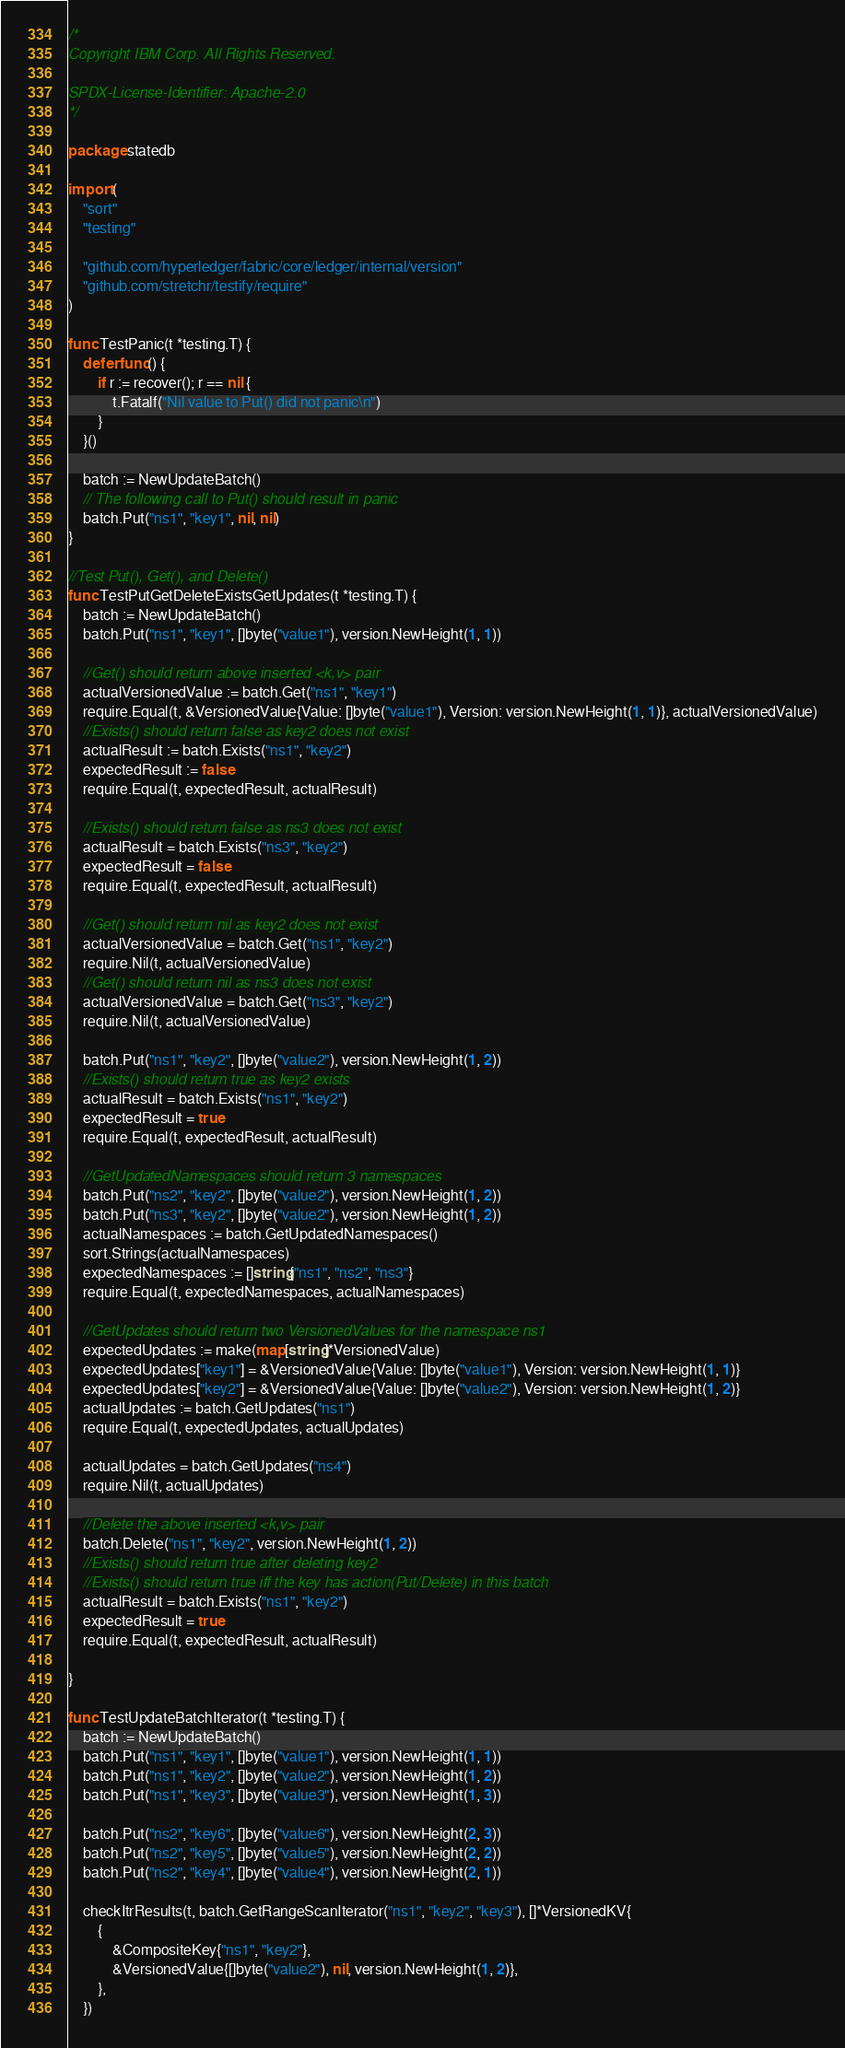<code> <loc_0><loc_0><loc_500><loc_500><_Go_>/*
Copyright IBM Corp. All Rights Reserved.

SPDX-License-Identifier: Apache-2.0
*/

package statedb

import (
	"sort"
	"testing"

	"github.com/hyperledger/fabric/core/ledger/internal/version"
	"github.com/stretchr/testify/require"
)

func TestPanic(t *testing.T) {
	defer func() {
		if r := recover(); r == nil {
			t.Fatalf("Nil value to Put() did not panic\n")
		}
	}()

	batch := NewUpdateBatch()
	// The following call to Put() should result in panic
	batch.Put("ns1", "key1", nil, nil)
}

//Test Put(), Get(), and Delete()
func TestPutGetDeleteExistsGetUpdates(t *testing.T) {
	batch := NewUpdateBatch()
	batch.Put("ns1", "key1", []byte("value1"), version.NewHeight(1, 1))

	//Get() should return above inserted <k,v> pair
	actualVersionedValue := batch.Get("ns1", "key1")
	require.Equal(t, &VersionedValue{Value: []byte("value1"), Version: version.NewHeight(1, 1)}, actualVersionedValue)
	//Exists() should return false as key2 does not exist
	actualResult := batch.Exists("ns1", "key2")
	expectedResult := false
	require.Equal(t, expectedResult, actualResult)

	//Exists() should return false as ns3 does not exist
	actualResult = batch.Exists("ns3", "key2")
	expectedResult = false
	require.Equal(t, expectedResult, actualResult)

	//Get() should return nil as key2 does not exist
	actualVersionedValue = batch.Get("ns1", "key2")
	require.Nil(t, actualVersionedValue)
	//Get() should return nil as ns3 does not exist
	actualVersionedValue = batch.Get("ns3", "key2")
	require.Nil(t, actualVersionedValue)

	batch.Put("ns1", "key2", []byte("value2"), version.NewHeight(1, 2))
	//Exists() should return true as key2 exists
	actualResult = batch.Exists("ns1", "key2")
	expectedResult = true
	require.Equal(t, expectedResult, actualResult)

	//GetUpdatedNamespaces should return 3 namespaces
	batch.Put("ns2", "key2", []byte("value2"), version.NewHeight(1, 2))
	batch.Put("ns3", "key2", []byte("value2"), version.NewHeight(1, 2))
	actualNamespaces := batch.GetUpdatedNamespaces()
	sort.Strings(actualNamespaces)
	expectedNamespaces := []string{"ns1", "ns2", "ns3"}
	require.Equal(t, expectedNamespaces, actualNamespaces)

	//GetUpdates should return two VersionedValues for the namespace ns1
	expectedUpdates := make(map[string]*VersionedValue)
	expectedUpdates["key1"] = &VersionedValue{Value: []byte("value1"), Version: version.NewHeight(1, 1)}
	expectedUpdates["key2"] = &VersionedValue{Value: []byte("value2"), Version: version.NewHeight(1, 2)}
	actualUpdates := batch.GetUpdates("ns1")
	require.Equal(t, expectedUpdates, actualUpdates)

	actualUpdates = batch.GetUpdates("ns4")
	require.Nil(t, actualUpdates)

	//Delete the above inserted <k,v> pair
	batch.Delete("ns1", "key2", version.NewHeight(1, 2))
	//Exists() should return true after deleting key2
	//Exists() should return true iff the key has action(Put/Delete) in this batch
	actualResult = batch.Exists("ns1", "key2")
	expectedResult = true
	require.Equal(t, expectedResult, actualResult)

}

func TestUpdateBatchIterator(t *testing.T) {
	batch := NewUpdateBatch()
	batch.Put("ns1", "key1", []byte("value1"), version.NewHeight(1, 1))
	batch.Put("ns1", "key2", []byte("value2"), version.NewHeight(1, 2))
	batch.Put("ns1", "key3", []byte("value3"), version.NewHeight(1, 3))

	batch.Put("ns2", "key6", []byte("value6"), version.NewHeight(2, 3))
	batch.Put("ns2", "key5", []byte("value5"), version.NewHeight(2, 2))
	batch.Put("ns2", "key4", []byte("value4"), version.NewHeight(2, 1))

	checkItrResults(t, batch.GetRangeScanIterator("ns1", "key2", "key3"), []*VersionedKV{
		{
			&CompositeKey{"ns1", "key2"},
			&VersionedValue{[]byte("value2"), nil, version.NewHeight(1, 2)},
		},
	})
</code> 